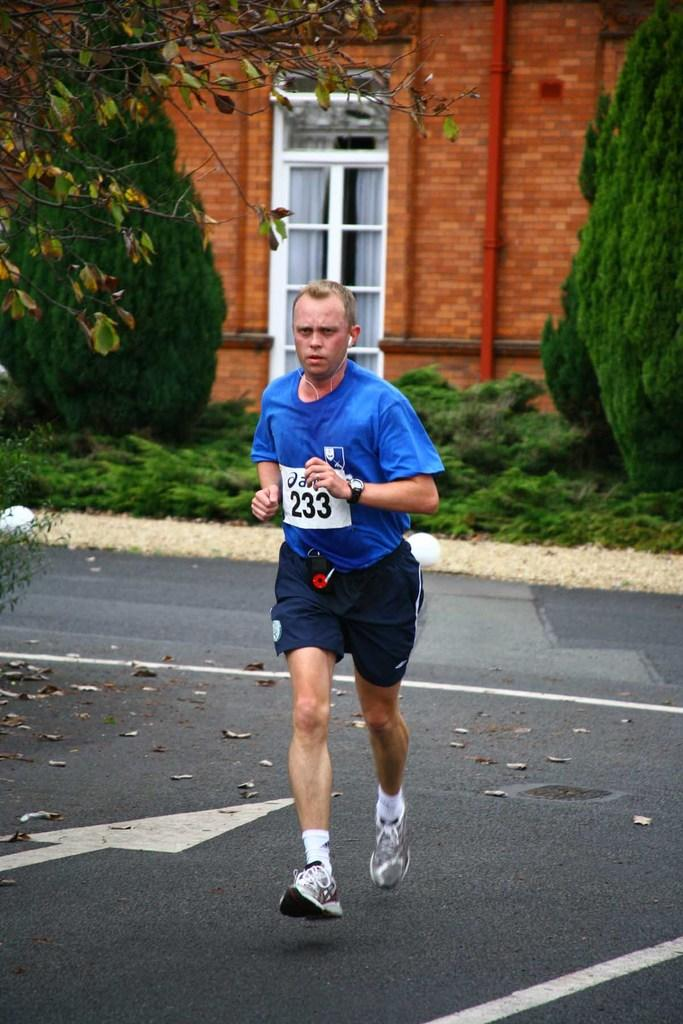<image>
Relay a brief, clear account of the picture shown. A man running a marathon with the number "233" as his identification. 